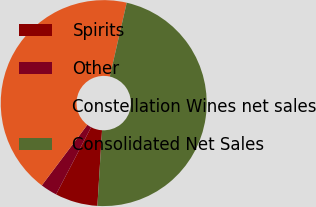Convert chart to OTSL. <chart><loc_0><loc_0><loc_500><loc_500><pie_chart><fcel>Spirits<fcel>Other<fcel>Constellation Wines net sales<fcel>Consolidated Net Sales<nl><fcel>6.68%<fcel>2.61%<fcel>43.32%<fcel>47.39%<nl></chart> 